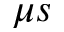Convert formula to latex. <formula><loc_0><loc_0><loc_500><loc_500>\mu s</formula> 